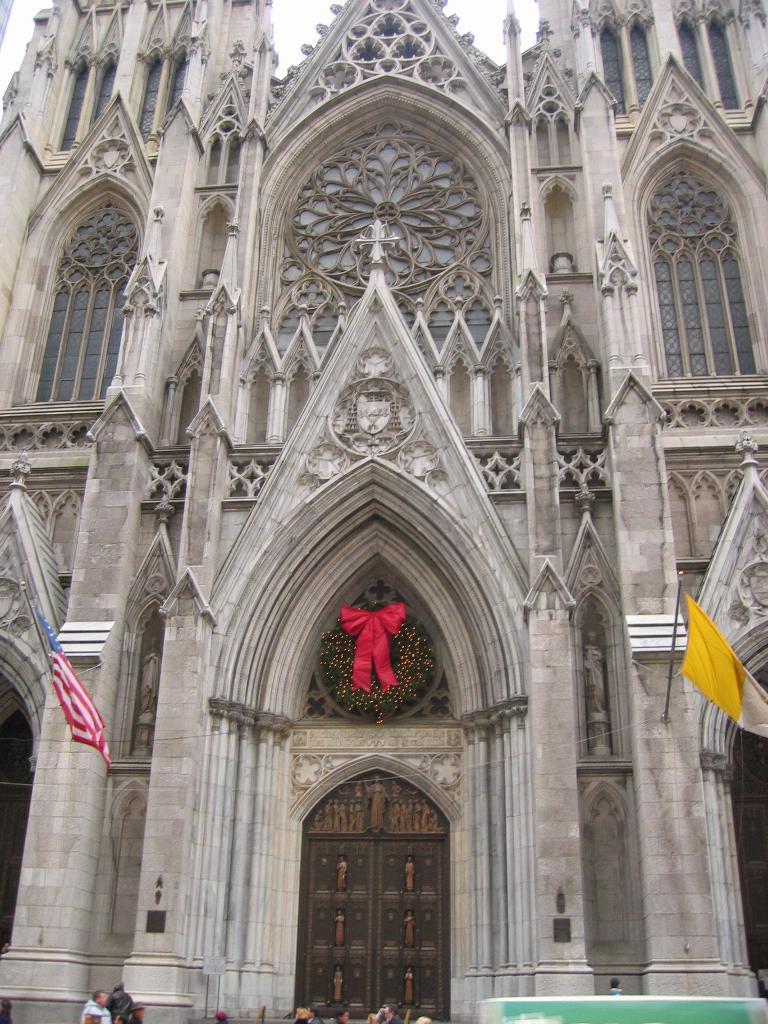How would you summarize this image in a sentence or two? In the foreground of this image, there is a church and two flags on either side of the entrance. On bottom side of the image, there are persons and a vehicle. 